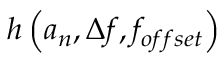Convert formula to latex. <formula><loc_0><loc_0><loc_500><loc_500>h \left ( a _ { n } , \Delta f , f _ { o f f s e t } \right )</formula> 